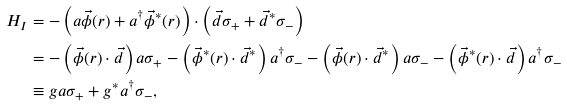Convert formula to latex. <formula><loc_0><loc_0><loc_500><loc_500>H _ { I } & = - \left ( a \vec { \phi } ( r ) + a ^ { \dagger } \vec { \phi } ^ { * } ( r ) \right ) \cdot \left ( \vec { d } \sigma _ { + } + \vec { d } ^ { * } \sigma _ { - } \right ) \\ & = - \left ( \vec { \phi } ( r ) \cdot \vec { d } \right ) a \sigma _ { + } - \left ( \vec { \phi } ^ { * } ( r ) \cdot \vec { d } ^ { * } \right ) a ^ { \dagger } \sigma _ { - } - \left ( \vec { \phi } ( r ) \cdot \vec { d } ^ { * } \right ) a \sigma _ { - } - \left ( \vec { \phi } ^ { * } ( r ) \cdot \vec { d } \right ) a ^ { \dagger } \sigma _ { - } \\ & \equiv g a \sigma _ { + } + g ^ { * } a ^ { \dagger } \sigma _ { - } ,</formula> 